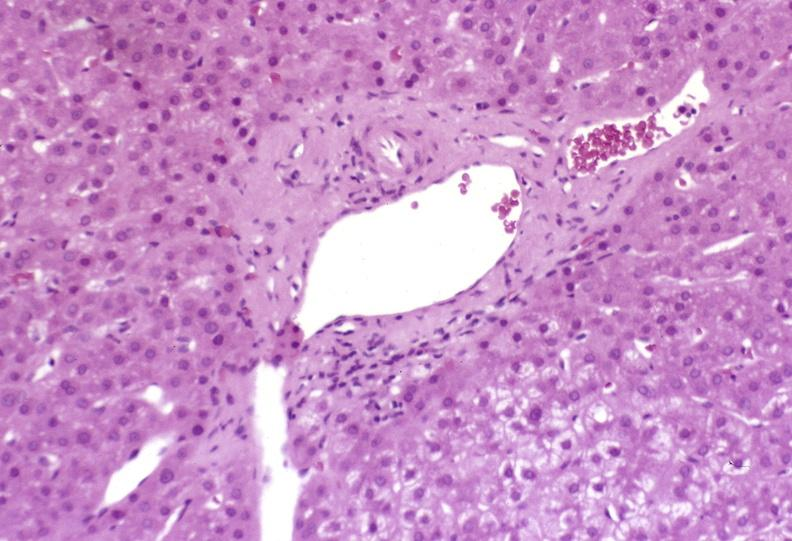s exposure present?
Answer the question using a single word or phrase. No 